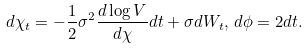Convert formula to latex. <formula><loc_0><loc_0><loc_500><loc_500>d \chi _ { t } = - \frac { 1 } { 2 } \sigma ^ { 2 } \frac { d \log V } { d \chi } d t + \sigma d W _ { t } , \, d \phi = 2 d t . \\</formula> 